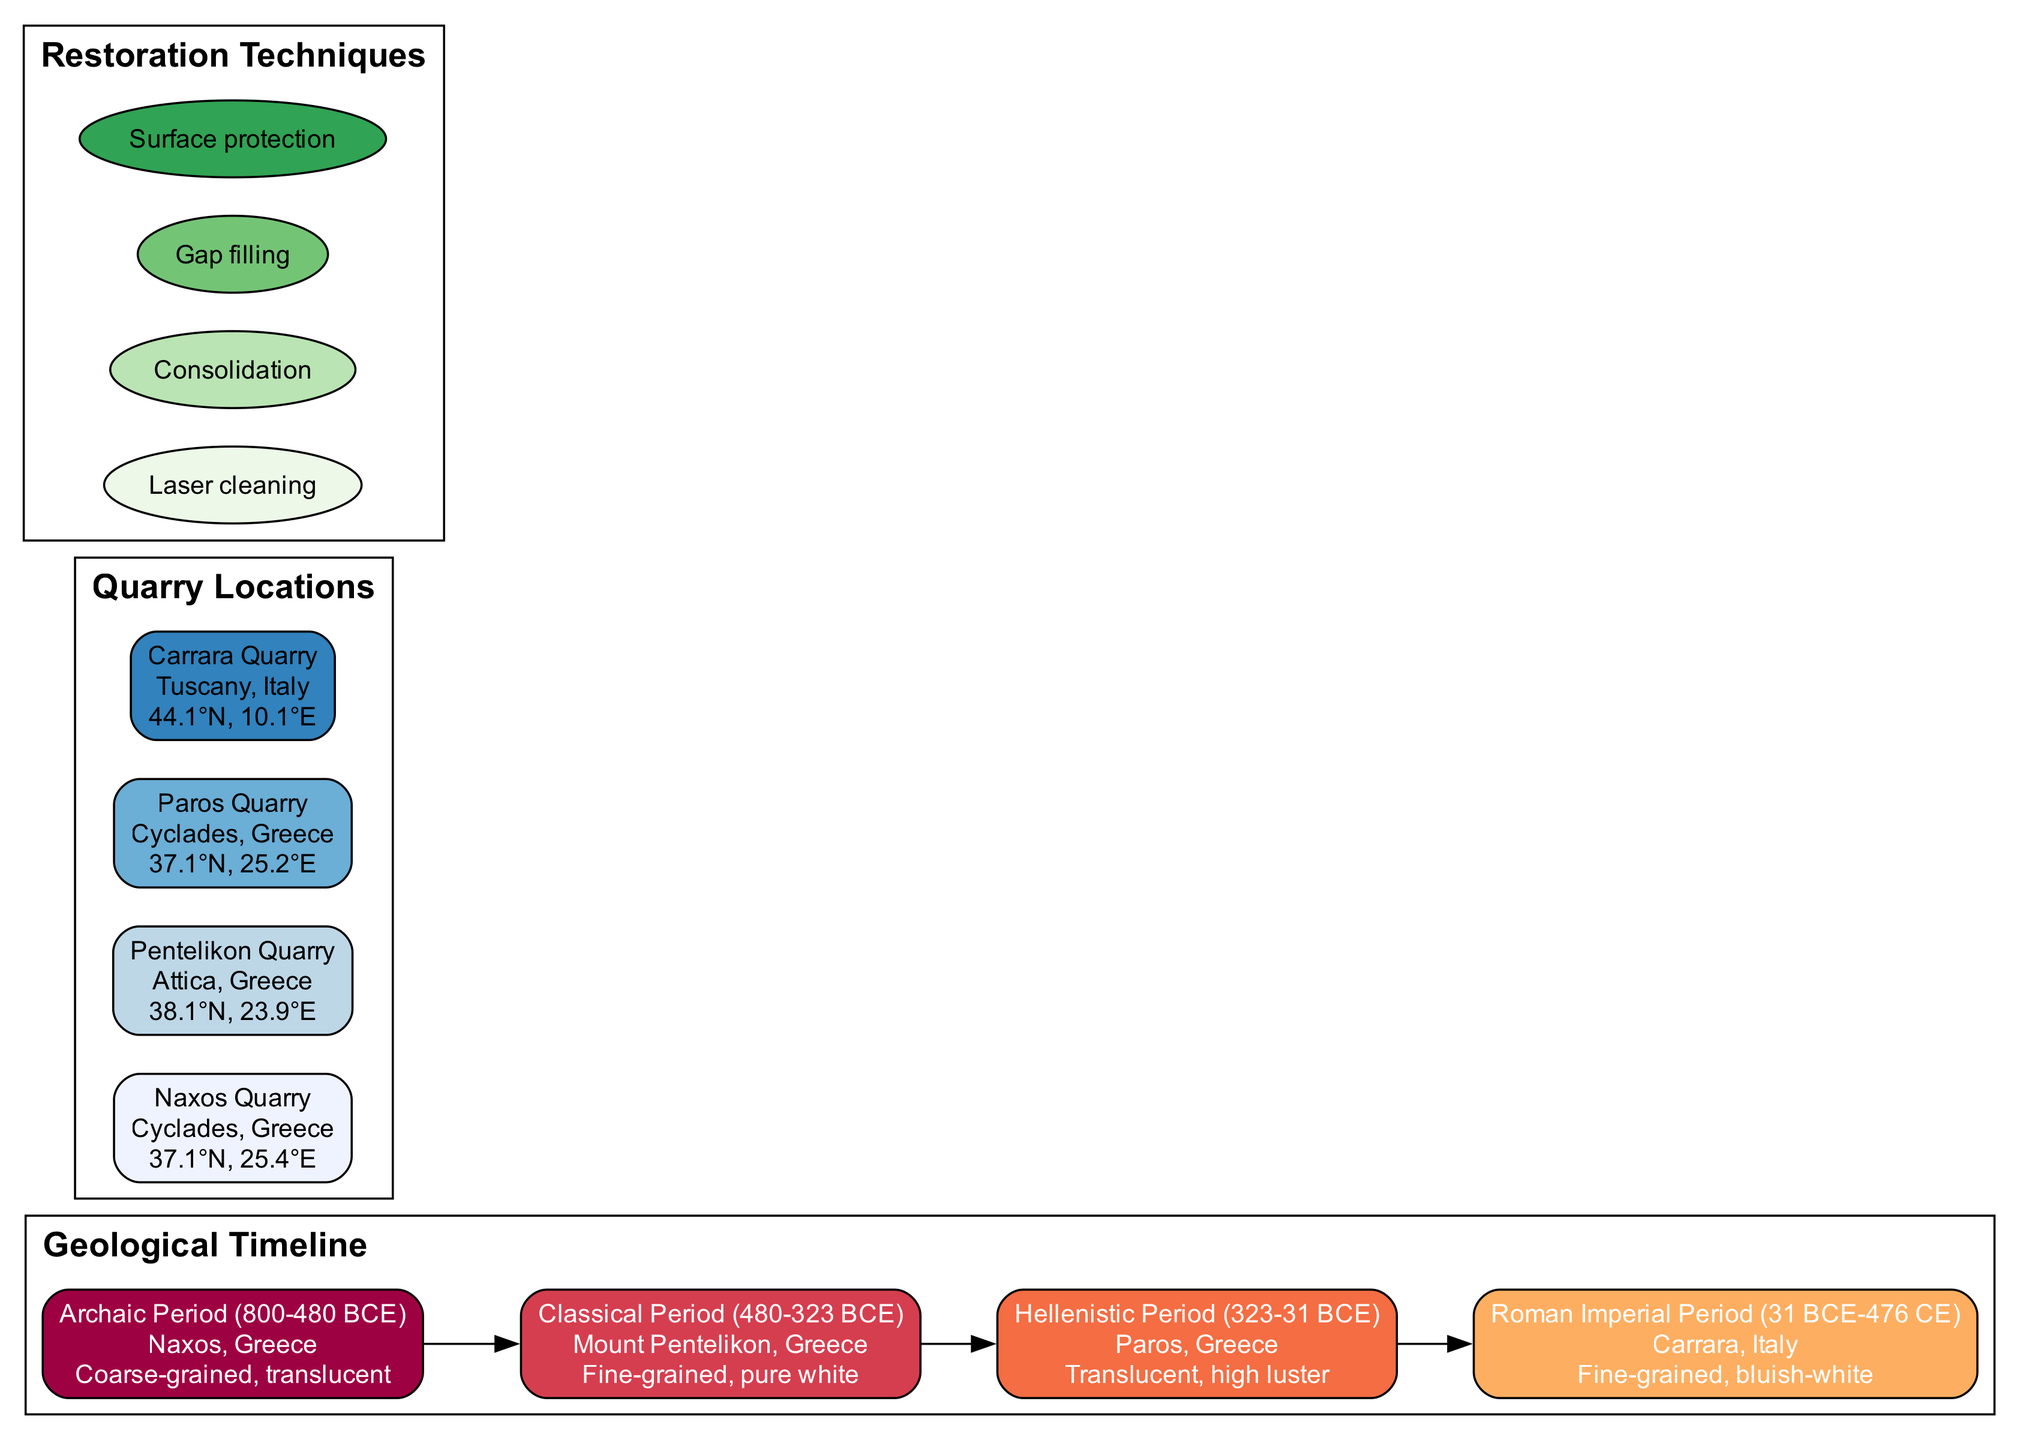What is the marble source from the Archaic Period? The diagram lists the marble source from the Archaic Period as Naxos, Greece.
Answer: Naxos, Greece What type of marble is associated with the Classical Period? According to the diagram, the type of marble associated with the Classical Period is fine-grained and pure white.
Answer: Fine-grained, pure white How many quarry locations are identified in the diagram? The diagram shows a total of four quarry locations, which can be counted from the listed quarry nodes.
Answer: 4 Which quarry is located in Tuscany, Italy? From the diagram, the quarry located in Tuscany, Italy is Carrara Quarry.
Answer: Carrara Quarry What feature characterizes the marble from Paros, Greece? The diagram states that the marble from Paros, Greece is translucent and has a high luster.
Answer: Translucent, high luster Which period corresponds to the marble source Carrara? To determine the period, we can follow the connection from the quarry Carrara in the diagram, which links to the Roman Imperial Period.
Answer: Roman Imperial Period Which restoration technique is used for surface protection? The diagram lists surface protection as one of the restoration techniques mentioned in the restoration section.
Answer: Surface protection How many distinct periods are represented in the geological timeline? By reviewing the timeline section of the diagram, we can see that there are four distinct periods indicated in total.
Answer: 4 What type of feature does the marble from Naxos exhibit? The diagram indicates that the marble from Naxos exhibits a coarse-grained and translucent feature.
Answer: Coarse-grained, translucent 